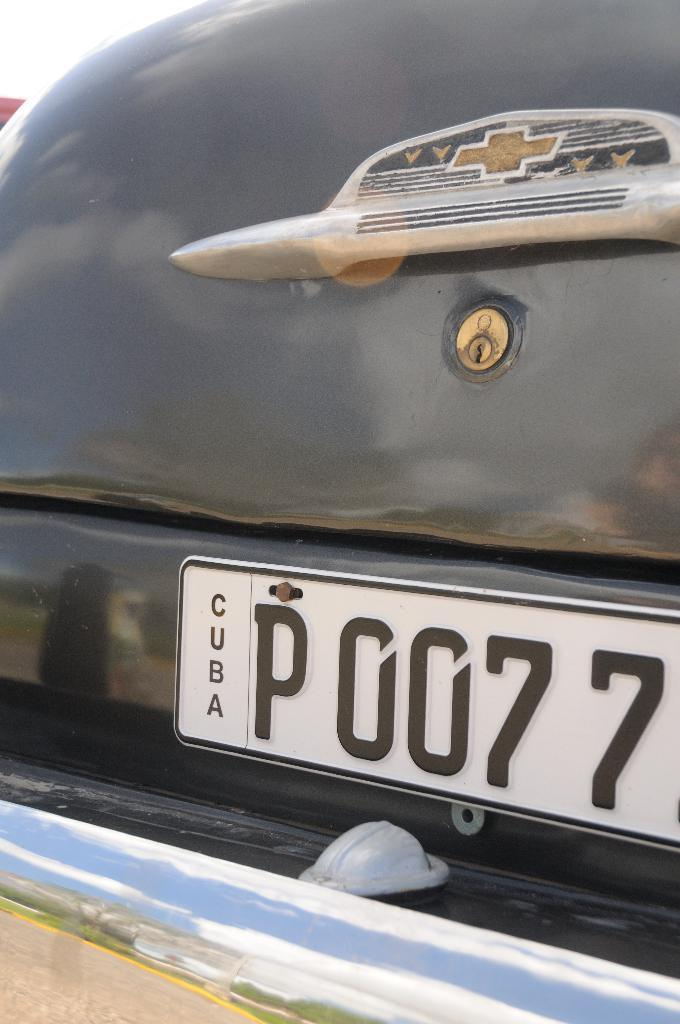What is the main subject of the image? There is a car in the image. What is the color of the car? The car is black in color. What part of the car can be seen in the image? The boot of the car is visible in the image. Is there any identifying information about the car visible in the image? Yes, the number plate of the car is visible in the image. What type of science experiment is being conducted with the yak in the image? There is no yak or science experiment present in the image; it features a black car with its boot and number plate visible. 